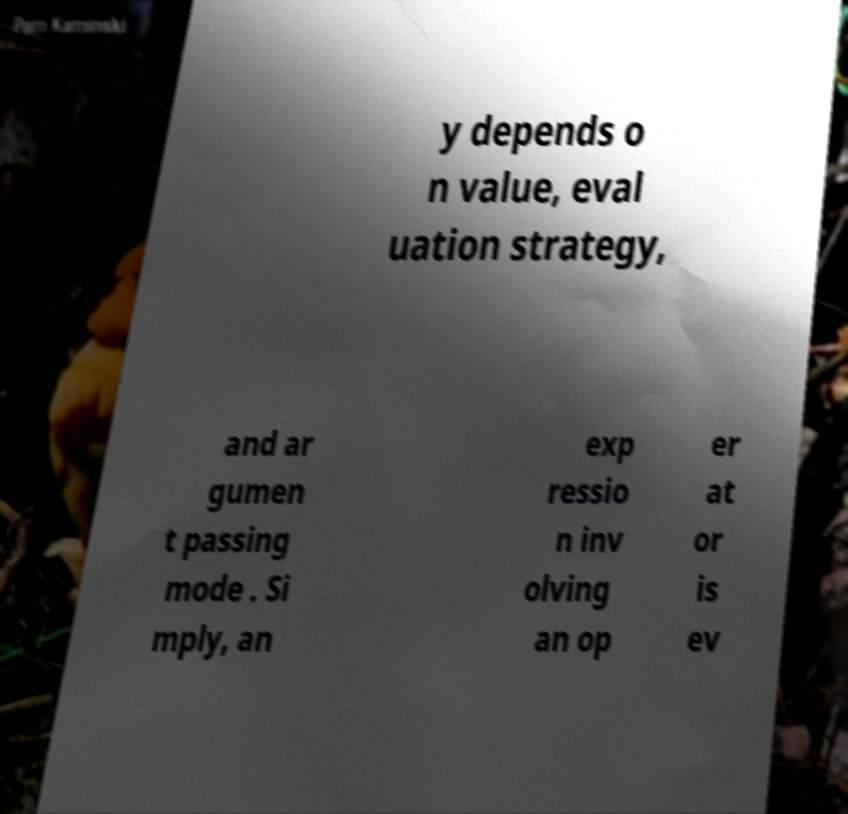Could you assist in decoding the text presented in this image and type it out clearly? y depends o n value, eval uation strategy, and ar gumen t passing mode . Si mply, an exp ressio n inv olving an op er at or is ev 